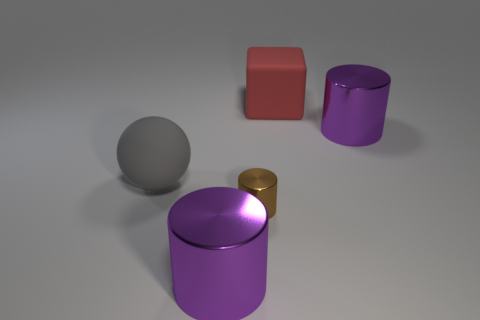Subtract all tiny cylinders. How many cylinders are left? 2 Add 4 purple metallic things. How many objects exist? 9 Subtract all brown cylinders. How many cylinders are left? 2 Subtract all blue cubes. How many purple cylinders are left? 2 Subtract all cubes. How many objects are left? 4 Subtract 1 cubes. How many cubes are left? 0 Add 4 big gray rubber objects. How many big gray rubber objects exist? 5 Subtract 0 blue blocks. How many objects are left? 5 Subtract all yellow cylinders. Subtract all purple blocks. How many cylinders are left? 3 Subtract all large matte cubes. Subtract all brown things. How many objects are left? 3 